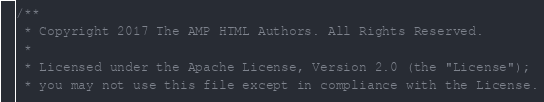Convert code to text. <code><loc_0><loc_0><loc_500><loc_500><_C_>/**
 * Copyright 2017 The AMP HTML Authors. All Rights Reserved.
 *
 * Licensed under the Apache License, Version 2.0 (the "License");
 * you may not use this file except in compliance with the License.</code> 